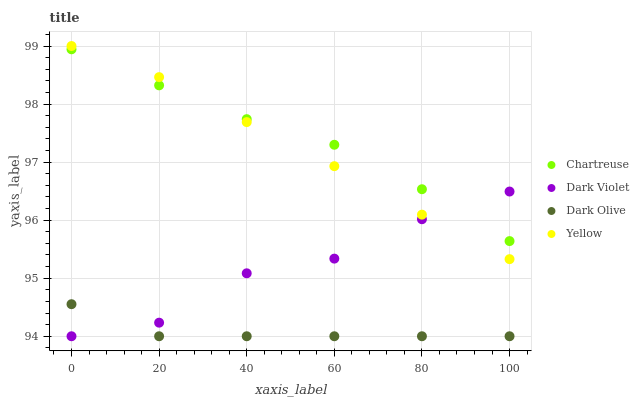Does Dark Olive have the minimum area under the curve?
Answer yes or no. Yes. Does Chartreuse have the maximum area under the curve?
Answer yes or no. Yes. Does Yellow have the minimum area under the curve?
Answer yes or no. No. Does Yellow have the maximum area under the curve?
Answer yes or no. No. Is Yellow the smoothest?
Answer yes or no. Yes. Is Dark Violet the roughest?
Answer yes or no. Yes. Is Dark Olive the smoothest?
Answer yes or no. No. Is Dark Olive the roughest?
Answer yes or no. No. Does Dark Olive have the lowest value?
Answer yes or no. Yes. Does Yellow have the lowest value?
Answer yes or no. No. Does Yellow have the highest value?
Answer yes or no. Yes. Does Dark Olive have the highest value?
Answer yes or no. No. Is Dark Olive less than Yellow?
Answer yes or no. Yes. Is Chartreuse greater than Dark Olive?
Answer yes or no. Yes. Does Dark Violet intersect Yellow?
Answer yes or no. Yes. Is Dark Violet less than Yellow?
Answer yes or no. No. Is Dark Violet greater than Yellow?
Answer yes or no. No. Does Dark Olive intersect Yellow?
Answer yes or no. No. 